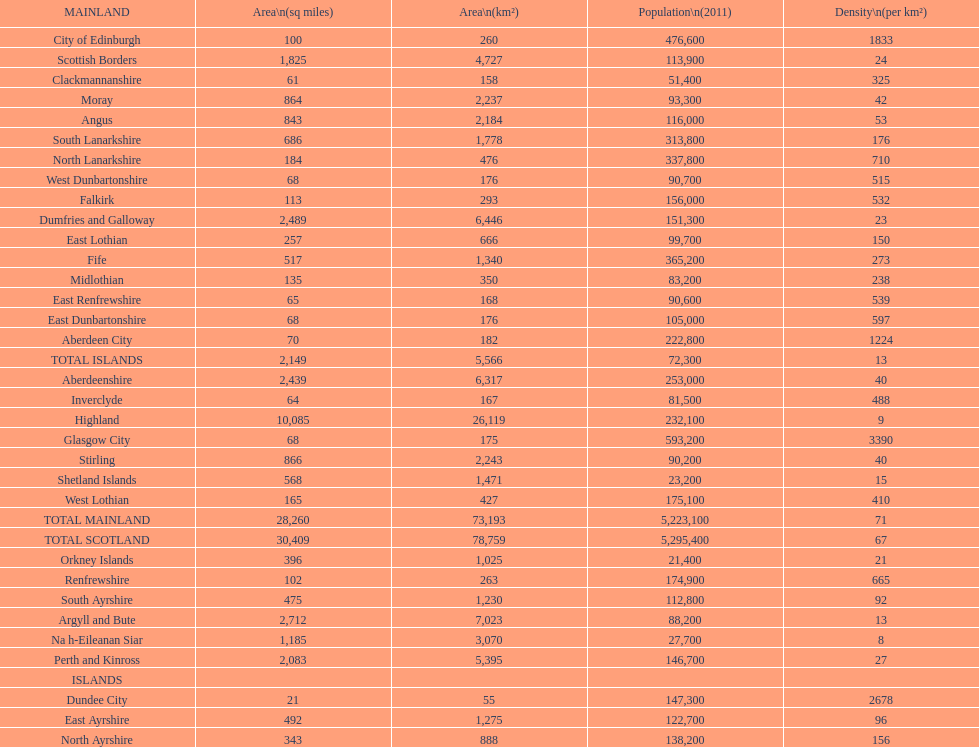Which mainland has the least population? Clackmannanshire. 